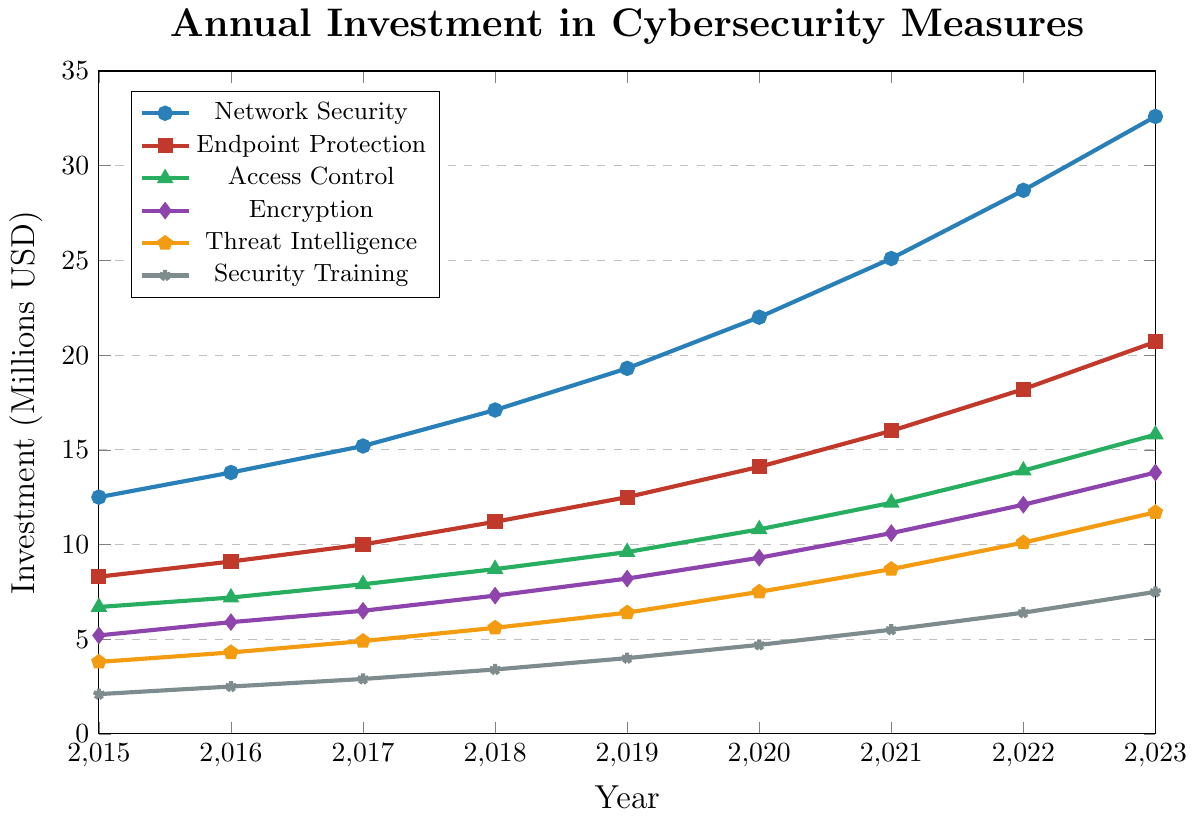What is the total investment in Network Security and Encryption in 2023? The investment in Network Security in 2023 is 32.6 million USD, and in Encryption, it is 13.8 million USD. Adding these amounts, we get 32.6 + 13.8 = 46.4 million USD.
Answer: 46.4 million USD Which security category had the highest investment in 2020? By comparing the investment in each category in 2020, Network Security has the highest investment at 22.0 million USD.
Answer: Network Security How did the investment in Endpoint Protection change from 2015 to 2023? The investment in Endpoint Protection in 2015 was 8.3 million USD and increased to 20.7 million USD in 2023. The change is 20.7 - 8.3 = 12.4 million USD.
Answer: 12.4 million USD Which year saw the greatest increase in investment in Threat Intelligence? By calculating the yearly change in Threat Intelligence from 2015 to 2023, the increase from 2019 (6.4 million USD) to 2020 (7.5 million USD) is the greatest, which is 7.5 - 6.4 = 1.1 million USD.
Answer: 2019-2020 What is the average annual investment in Access Control between 2018 and 2021? The investments in Access Control from 2018 to 2021 are 8.7, 9.6, 10.8, and 12.2 million USD, respectively. The average is (8.7 + 9.6 + 10.8 + 12.2) / 4 = 10.325 million USD.
Answer: 10.325 million USD How much more was invested in Network Security than in Security Training in 2021? The investment in Network Security in 2021 is 25.1 million USD, and in Security Training, it is 5.5 million USD. The difference is 25.1 - 5.5 = 19.6 million USD.
Answer: 19.6 million USD What color represents Encryption in the figure? Encryption is represented by the purple color (diamond markers).
Answer: Purple Which security category saw a steady increase in investment each year without any decreases? By analyzing the trends, all categories including Network Security, Endpoint Protection, Access Control, Encryption, Threat Intelligence, and Security Training saw steady annual increases without any decreases.
Answer: All categories What is the total investment in all security measures combined in 2020? The investments in 2020 are Network Security (22.0), Endpoint Protection (14.1), Access Control (10.8), Encryption (9.3), Threat Intelligence (7.5), and Security Training (4.7). The total is 22.0 + 14.1 + 10.8 + 9.3 + 7.5 + 4.7 = 68.4 million USD.
Answer: 68.4 million USD Between 2015 and 2023, which year had the highest relative increase in investment from the previous year for Endpoint Protection? The relative increase for each year is calculated as follows: (2016: (9.1-8.3)/8.3 = 0.096), (2017: (10.0-9.1)/9.1 = 0.099), (2018: (11.2-10.0)/10.0 = 0.12), (2019: (12.5-11.2)/11.2 = 0.116), (2020: (14.1-12.5)/12.5 = 0.128), (2021: (16.0-14.1)/14.1 = 0.135), (2022: (18.2-16.0)/16.0 = 0.138), (2023: (20.7-18.2)/18.2 = 0.137). The year 2022 had the highest relative increase at 13.8%.
Answer: 2022 